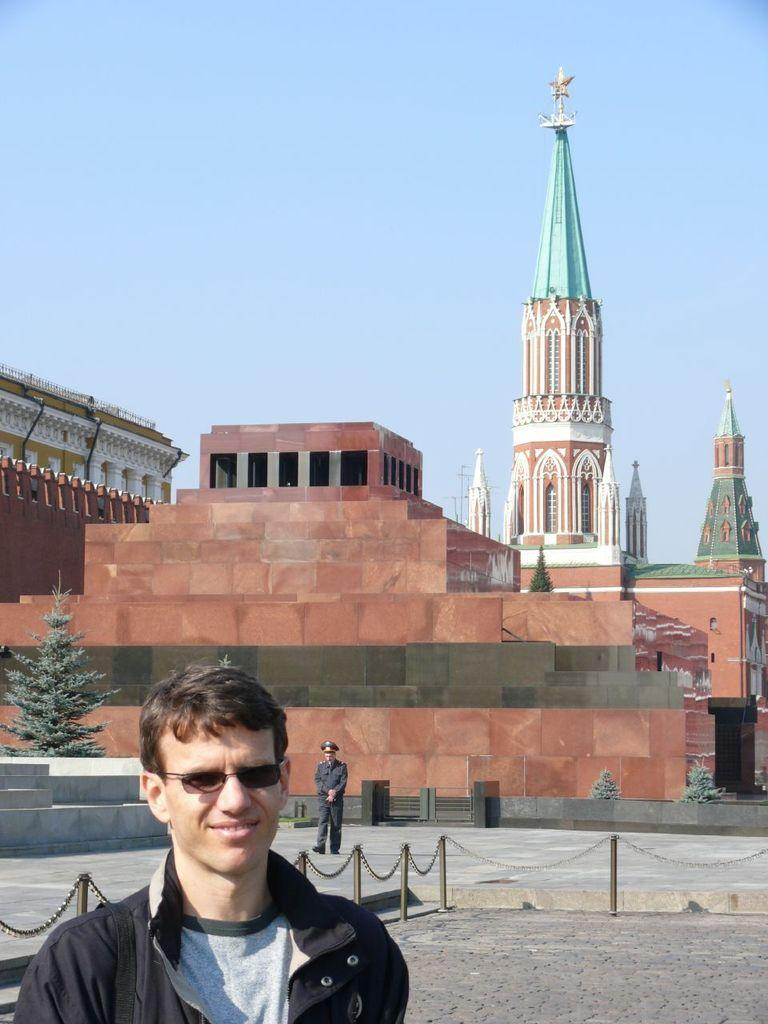What is the man in the image wearing? The man in the image is wearing goggles. What expression does the man have? The man is smiling. What can be seen in the background of the image? In the background of the image, there is a person walking, a fence, trees, buildings, and the sky. What type of coach can be seen in the image? There is no coach present in the image. What material is the tank made of in the image? There is no tank present in the image. 